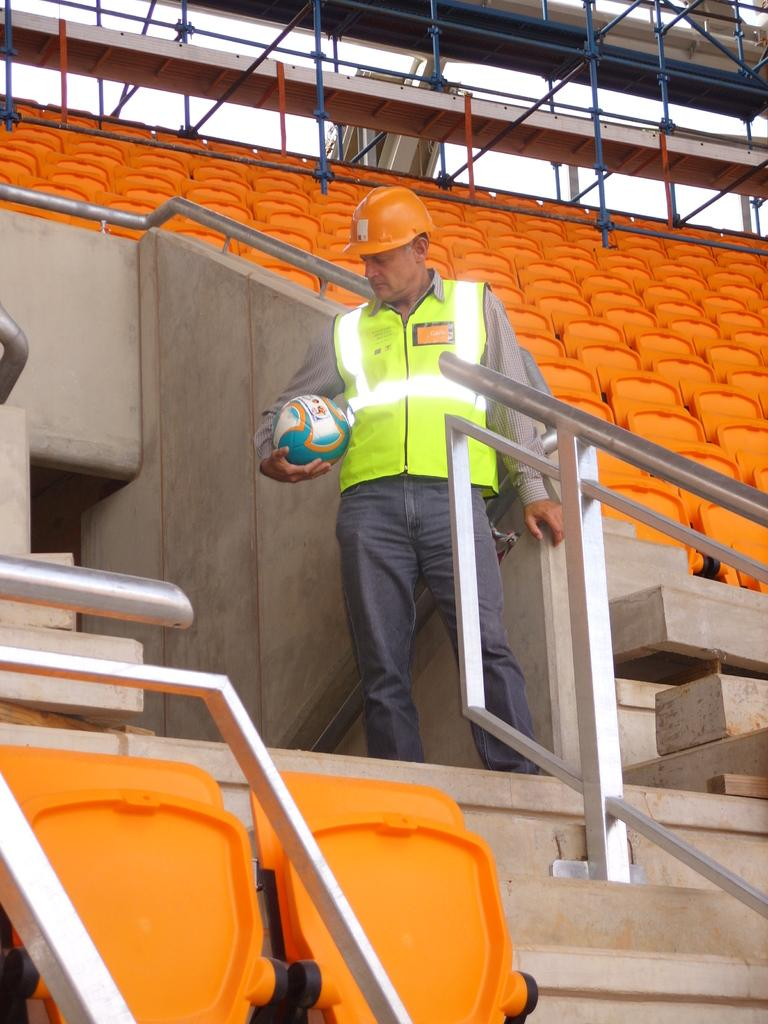Who is present in the image? There is a man in the image. What is the man holding in the image? The man is holding a ball. What is the man's posture in the image? The man is standing. What can be seen in the background of the image? There are chairs and stairs in the background of the image. What type of veil is draped over the man's head in the image? There is no veil present in the image; the man is not wearing any head covering. 